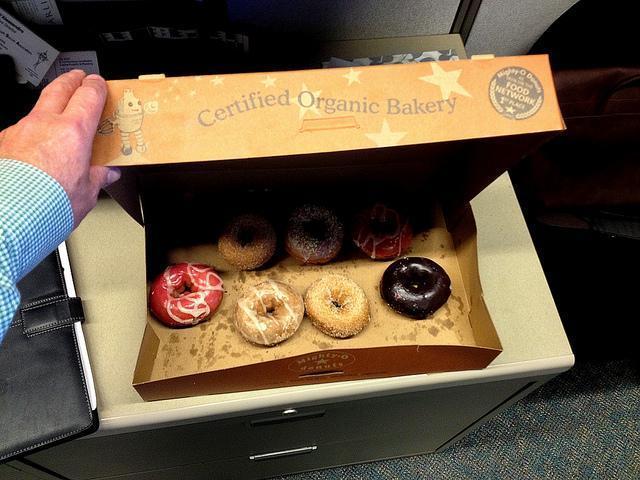How many donuts are in the picture?
Give a very brief answer. 7. How many people are in the photo?
Give a very brief answer. 1. 